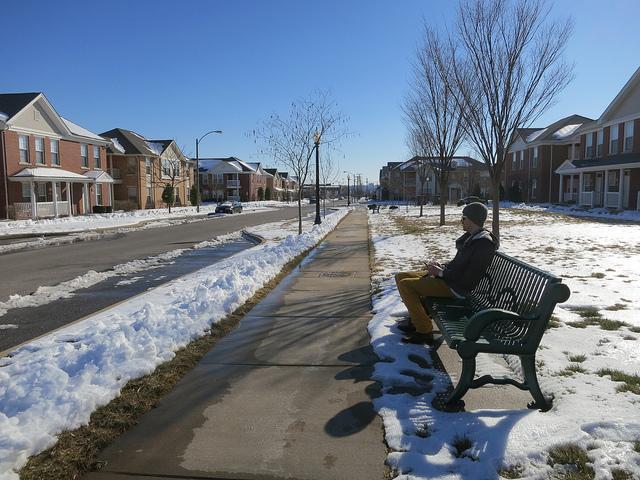In which area does the man wait?
Pick the correct solution from the four options below to address the question.
Options: Rural, forest, suburban, urban. Suburban. 